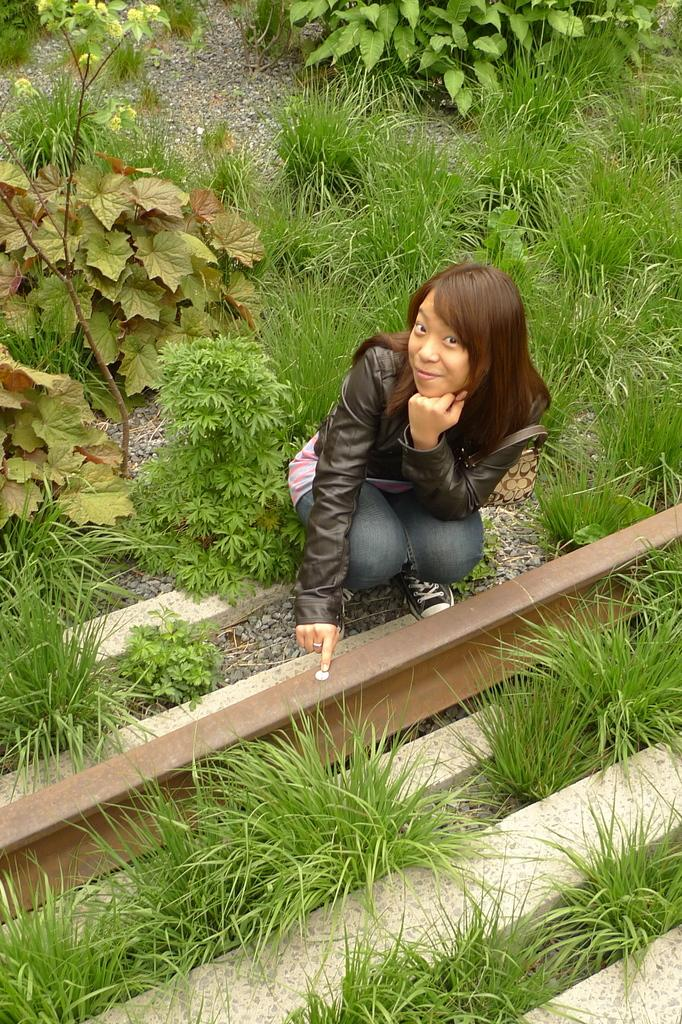Who is the main subject in the image? There is a lady in the image. What is the lady doing in the image? The lady is in a crouched position. What type of surface is the lady on in the image? There is grass on the ground in the image. What other vegetation can be seen on the ground in the image? There are plants on the ground in the image. Can you see any cows running in the image? There are no cows or running depicted in the image. 